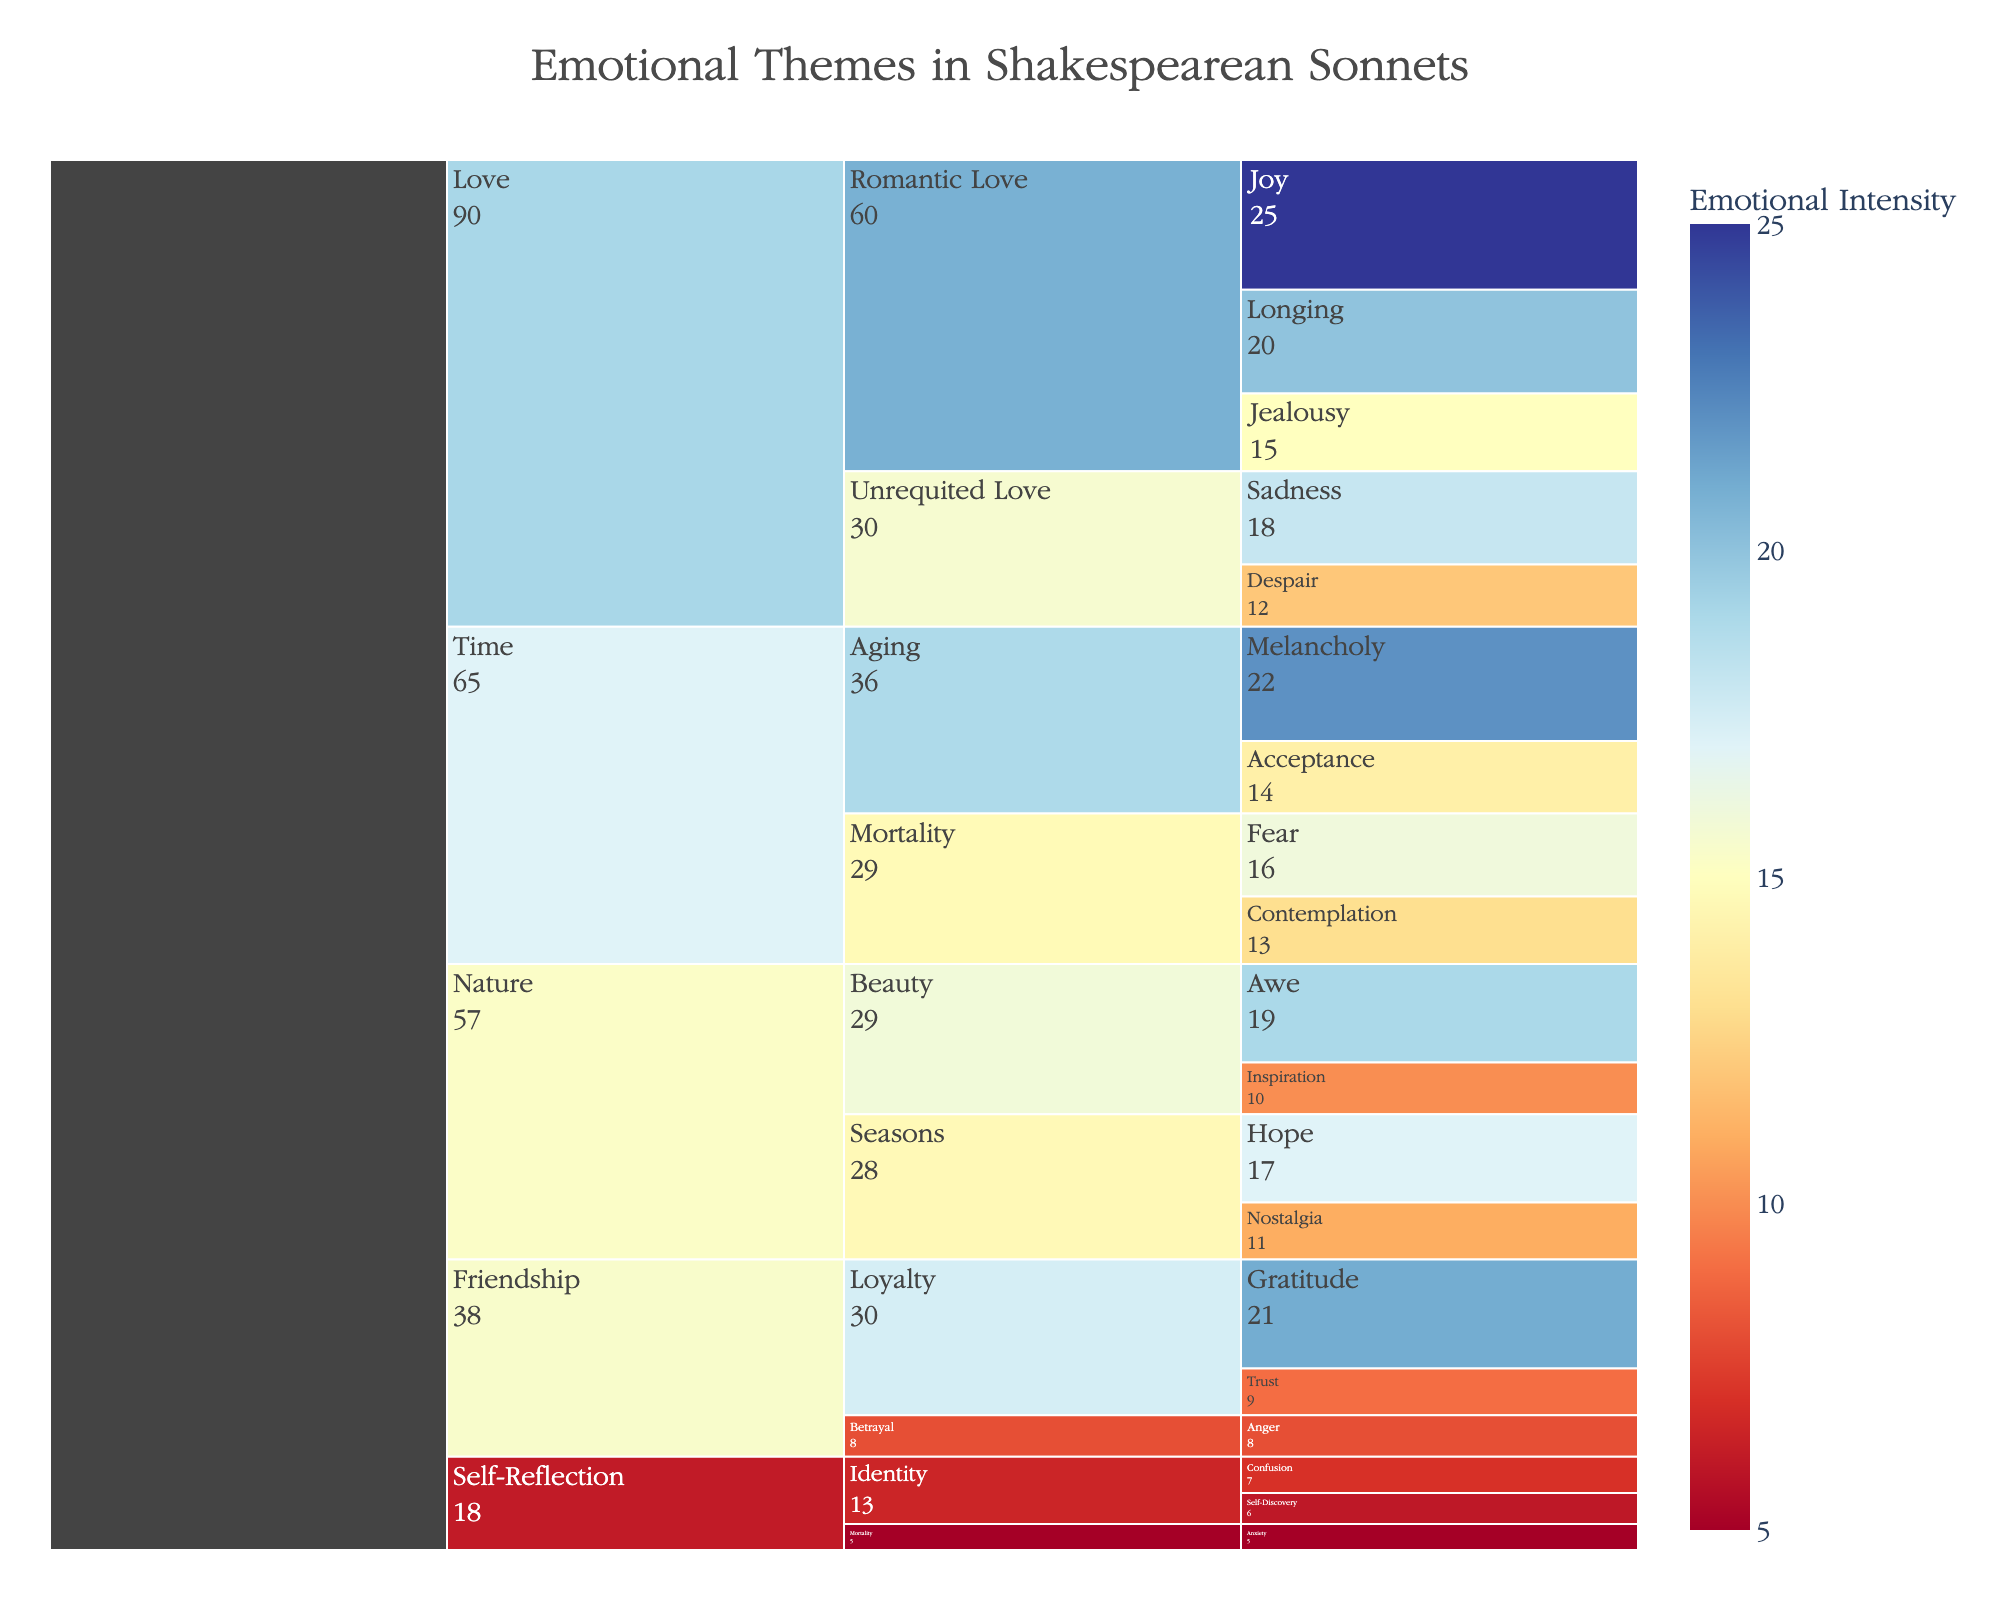What's the category with the highest total value? Sum up the values for each category and compare them: Love (25+20+15+18+12=90), Time (22+14+16+13=65), Nature (17+11+19+10=57), Friendship (21+9+8=38), Self-Reflection (7+6+5=18). Love has the highest total value.
Answer: Love What subcategory under the "Love" category has the highest value? Compare the sum of values for each subcategory under Love: Romantic Love (25+20+15=60) and Unrequited Love (18+12=30). Romantic Love has the highest value.
Answer: Romantic Love Which emotion in the "Romantic Love" subcategory has the lowest value? Compare the values of emotions in Romantic Love: Joy (25), Longing (20), Jealousy (15). Jealousy has the lowest value.
Answer: Jealousy What's the combined value of "Hope" and "Nostalgia" in the "Seasons" subcategory? Add the values of Hope (17) and Nostalgia (11) in the Seasons subcategory. 17 + 11 = 28.
Answer: 28 Which subcategory in "Time" has the highest single emotion value? Compare the values of emotions in Aging (Melancholy = 22, Acceptance = 14) vs. Mortality (Fear = 16, Contemplation = 13). Melancholy in Aging has the highest value at 22.
Answer: Aging How does the value for "Gratitude" compare to "Trust" in the "Loyalty" subcategory? The value for Gratitude is 21 and for Trust is 9. So, Gratitude is greater than Trust.
Answer: Greater What is the total value for the "Beauty" subcategory under "Nature"? Add the values of Awe (19) and Inspiration (10). 19 + 10 = 29.
Answer: 29 Which category has the fewest subcategories? Count the subcategories for each category: Love (2), Time (2), Nature (2), Friendship (2), Self-Reflection (2). All categories have equal number of subcategories.
Answer: All equal What is the emotion with the lowest value, and in which subcategory and category does it belong? The lowest value emotion is Anxiety with a value of 5 in the Mortality subcategory under Self-Reflection.
Answer: Anxiety, Mortality, Self-Reflection What’s the average value of emotions in the "Friendship" category? Sum the values (21+9+8=38) and divide by the number of emotions (3). 38 / 3 = 12.67.
Answer: 12.67 